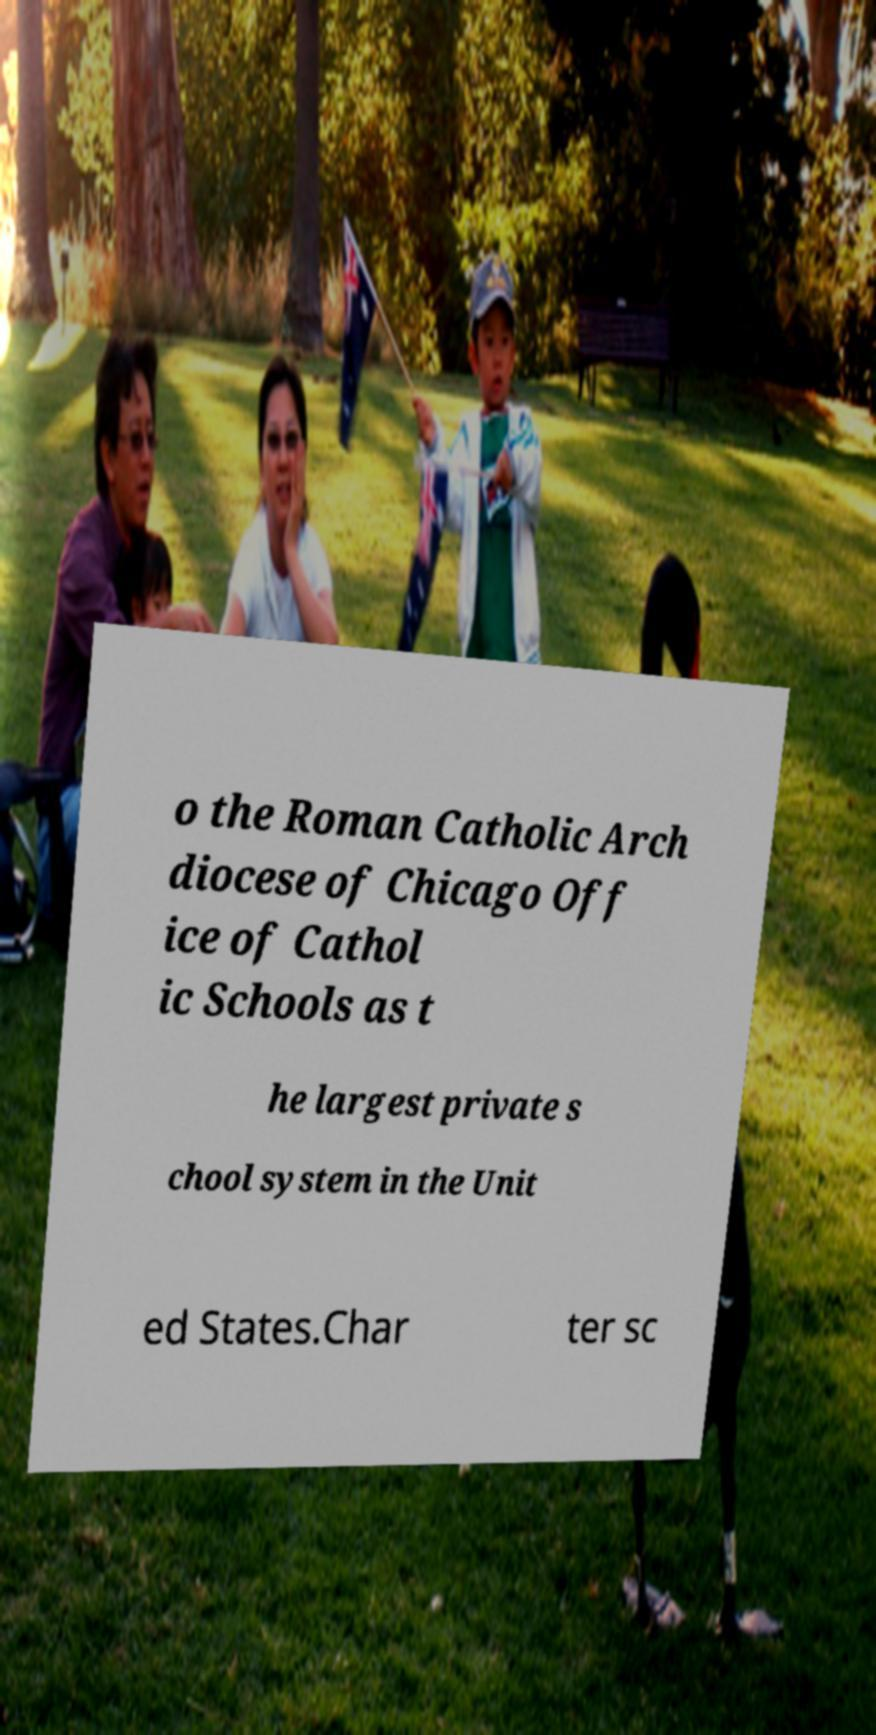There's text embedded in this image that I need extracted. Can you transcribe it verbatim? o the Roman Catholic Arch diocese of Chicago Off ice of Cathol ic Schools as t he largest private s chool system in the Unit ed States.Char ter sc 